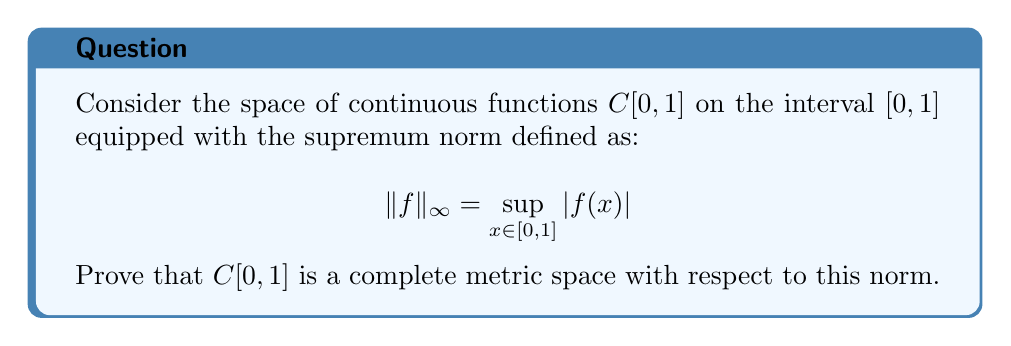Solve this math problem. To prove that $C[0,1]$ is complete, we need to show that every Cauchy sequence in this space converges to an element within the space. Let's proceed step by step:

1) Let $(f_n)$ be a Cauchy sequence in $C[0,1]$. This means that for any $\epsilon > 0$, there exists an $N \in \mathbb{N}$ such that for all $m, n \geq N$:

   $$\|f_m - f_n\|_{\infty} < \epsilon$$

2) This implies that for any $x \in [0,1]$ and $m, n \geq N$:

   $$|f_m(x) - f_n(x)| \leq \|f_m - f_n\|_{\infty} < \epsilon$$

3) Therefore, for each fixed $x \in [0,1]$, the sequence $(f_n(x))$ is a Cauchy sequence in $\mathbb{R}$. Since $\mathbb{R}$ is complete, this sequence converges to some real number. Let's call this limit $f(x)$:

   $$f(x) = \lim_{n \to \infty} f_n(x)$$

4) Now we have defined a function $f: [0,1] \to \mathbb{R}$. We need to show that:
   a) $f$ is continuous
   b) $f_n$ converges uniformly to $f$

5) To prove continuity, let $x, y \in [0,1]$ and $\epsilon > 0$. Choose $N$ such that for all $n, m \geq N$, $\|f_n - f_m\|_{\infty} < \epsilon/3$. Then:

   $$\begin{align*}
   |f(x) - f(y)| &\leq |f(x) - f_N(x)| + |f_N(x) - f_N(y)| + |f_N(y) - f(y)| \\
   &< \epsilon/3 + |f_N(x) - f_N(y)| + \epsilon/3
   \end{align*}$$

   Since $f_N$ is continuous, we can choose $\delta > 0$ such that $|x-y| < \delta$ implies $|f_N(x) - f_N(y)| < \epsilon/3$. This proves $f$ is continuous.

6) To prove uniform convergence, let $\epsilon > 0$ and choose $N$ such that for all $m, n \geq N$, $\|f_m - f_n\|_{\infty} < \epsilon/2$. Then for any $x \in [0,1]$ and $n \geq N$:

   $$\begin{align*}
   |f(x) - f_n(x)| &= \lim_{m \to \infty} |f_m(x) - f_n(x)| \\
   &\leq \limsup_{m \to \infty} \|f_m - f_n\|_{\infty} \leq \epsilon/2 < \epsilon
   \end{align*}$$

   This proves $\|f - f_n\|_{\infty} < \epsilon$ for all $n \geq N$, i.e., uniform convergence.

7) Since $f$ is continuous and $f_n$ converges uniformly to $f$, we conclude that $f \in C[0,1]$ and $f_n \to f$ in the supremum norm.

Therefore, every Cauchy sequence in $C[0,1]$ converges to an element of $C[0,1]$, proving that $C[0,1]$ is complete with respect to the supremum norm.
Answer: $C[0,1]$ is a complete metric space with respect to the supremum norm. 